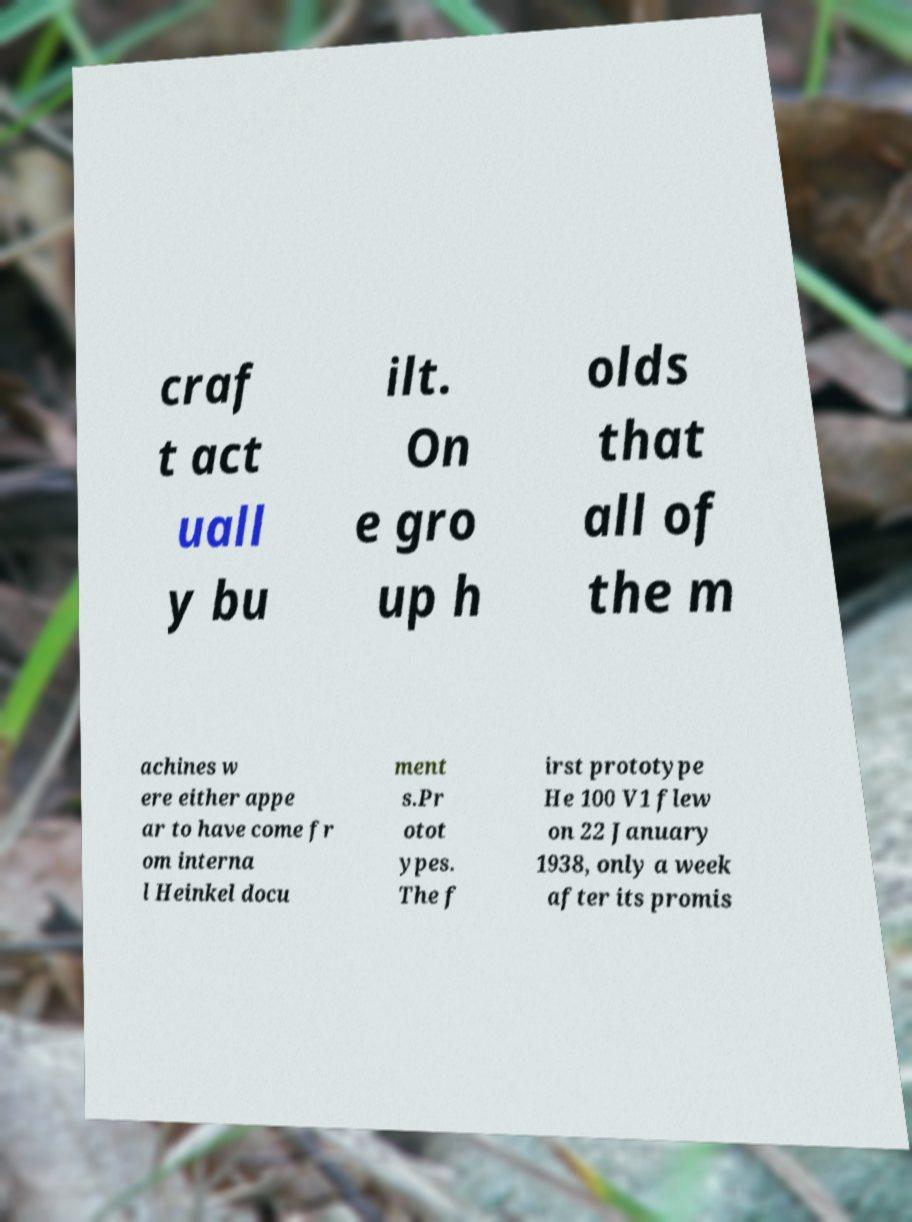What messages or text are displayed in this image? I need them in a readable, typed format. craf t act uall y bu ilt. On e gro up h olds that all of the m achines w ere either appe ar to have come fr om interna l Heinkel docu ment s.Pr otot ypes. The f irst prototype He 100 V1 flew on 22 January 1938, only a week after its promis 